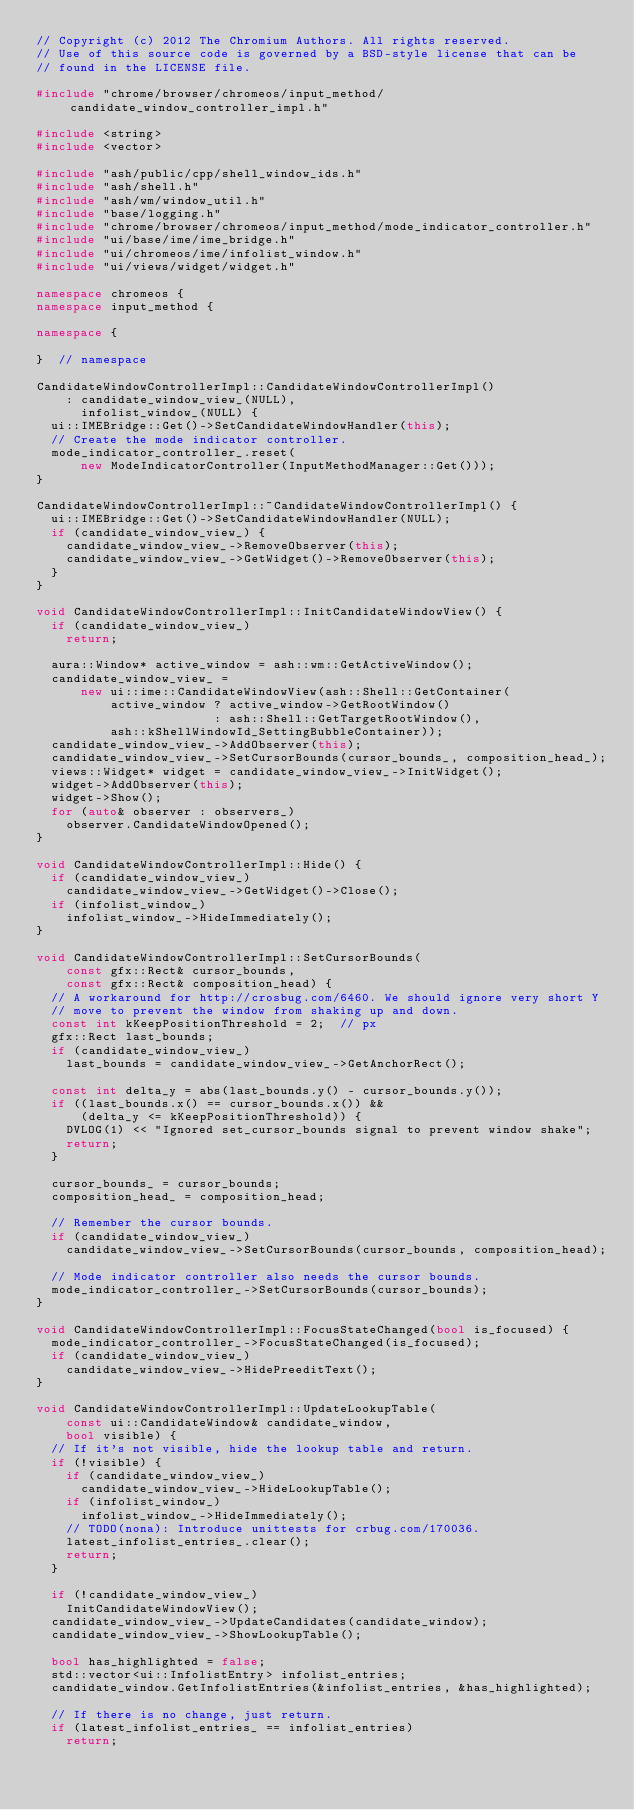<code> <loc_0><loc_0><loc_500><loc_500><_C++_>// Copyright (c) 2012 The Chromium Authors. All rights reserved.
// Use of this source code is governed by a BSD-style license that can be
// found in the LICENSE file.

#include "chrome/browser/chromeos/input_method/candidate_window_controller_impl.h"

#include <string>
#include <vector>

#include "ash/public/cpp/shell_window_ids.h"
#include "ash/shell.h"
#include "ash/wm/window_util.h"
#include "base/logging.h"
#include "chrome/browser/chromeos/input_method/mode_indicator_controller.h"
#include "ui/base/ime/ime_bridge.h"
#include "ui/chromeos/ime/infolist_window.h"
#include "ui/views/widget/widget.h"

namespace chromeos {
namespace input_method {

namespace {

}  // namespace

CandidateWindowControllerImpl::CandidateWindowControllerImpl()
    : candidate_window_view_(NULL),
      infolist_window_(NULL) {
  ui::IMEBridge::Get()->SetCandidateWindowHandler(this);
  // Create the mode indicator controller.
  mode_indicator_controller_.reset(
      new ModeIndicatorController(InputMethodManager::Get()));
}

CandidateWindowControllerImpl::~CandidateWindowControllerImpl() {
  ui::IMEBridge::Get()->SetCandidateWindowHandler(NULL);
  if (candidate_window_view_) {
    candidate_window_view_->RemoveObserver(this);
    candidate_window_view_->GetWidget()->RemoveObserver(this);
  }
}

void CandidateWindowControllerImpl::InitCandidateWindowView() {
  if (candidate_window_view_)
    return;

  aura::Window* active_window = ash::wm::GetActiveWindow();
  candidate_window_view_ =
      new ui::ime::CandidateWindowView(ash::Shell::GetContainer(
          active_window ? active_window->GetRootWindow()
                        : ash::Shell::GetTargetRootWindow(),
          ash::kShellWindowId_SettingBubbleContainer));
  candidate_window_view_->AddObserver(this);
  candidate_window_view_->SetCursorBounds(cursor_bounds_, composition_head_);
  views::Widget* widget = candidate_window_view_->InitWidget();
  widget->AddObserver(this);
  widget->Show();
  for (auto& observer : observers_)
    observer.CandidateWindowOpened();
}

void CandidateWindowControllerImpl::Hide() {
  if (candidate_window_view_)
    candidate_window_view_->GetWidget()->Close();
  if (infolist_window_)
    infolist_window_->HideImmediately();
}

void CandidateWindowControllerImpl::SetCursorBounds(
    const gfx::Rect& cursor_bounds,
    const gfx::Rect& composition_head) {
  // A workaround for http://crosbug.com/6460. We should ignore very short Y
  // move to prevent the window from shaking up and down.
  const int kKeepPositionThreshold = 2;  // px
  gfx::Rect last_bounds;
  if (candidate_window_view_)
    last_bounds = candidate_window_view_->GetAnchorRect();

  const int delta_y = abs(last_bounds.y() - cursor_bounds.y());
  if ((last_bounds.x() == cursor_bounds.x()) &&
      (delta_y <= kKeepPositionThreshold)) {
    DVLOG(1) << "Ignored set_cursor_bounds signal to prevent window shake";
    return;
  }

  cursor_bounds_ = cursor_bounds;
  composition_head_ = composition_head;

  // Remember the cursor bounds.
  if (candidate_window_view_)
    candidate_window_view_->SetCursorBounds(cursor_bounds, composition_head);

  // Mode indicator controller also needs the cursor bounds.
  mode_indicator_controller_->SetCursorBounds(cursor_bounds);
}

void CandidateWindowControllerImpl::FocusStateChanged(bool is_focused) {
  mode_indicator_controller_->FocusStateChanged(is_focused);
  if (candidate_window_view_)
    candidate_window_view_->HidePreeditText();
}

void CandidateWindowControllerImpl::UpdateLookupTable(
    const ui::CandidateWindow& candidate_window,
    bool visible) {
  // If it's not visible, hide the lookup table and return.
  if (!visible) {
    if (candidate_window_view_)
      candidate_window_view_->HideLookupTable();
    if (infolist_window_)
      infolist_window_->HideImmediately();
    // TODO(nona): Introduce unittests for crbug.com/170036.
    latest_infolist_entries_.clear();
    return;
  }

  if (!candidate_window_view_)
    InitCandidateWindowView();
  candidate_window_view_->UpdateCandidates(candidate_window);
  candidate_window_view_->ShowLookupTable();

  bool has_highlighted = false;
  std::vector<ui::InfolistEntry> infolist_entries;
  candidate_window.GetInfolistEntries(&infolist_entries, &has_highlighted);

  // If there is no change, just return.
  if (latest_infolist_entries_ == infolist_entries)
    return;
</code> 